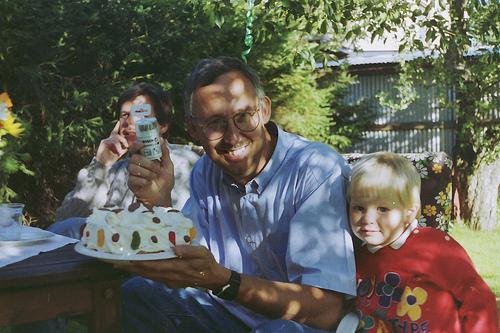Question: who is holding the cake?
Choices:
A. The woman.
B. The boy.
C. The man.
D. The girl.
Answer with the letter. Answer: C Question: what shape is the cake?
Choices:
A. Square.
B. Rectangle.
C. Round.
D. Octagonal.
Answer with the letter. Answer: C Question: where is the man wearing his watch?
Choices:
A. His wrist.
B. His ankle.
C. His torso.
D. His neck.
Answer with the letter. Answer: A Question: how many children are there?
Choices:
A. 5.
B. 1.
C. 2.
D. 6.
Answer with the letter. Answer: B Question: what is the table made of?
Choices:
A. Leather.
B. Plastic.
C. Metal.
D. Wood.
Answer with the letter. Answer: D 